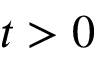Convert formula to latex. <formula><loc_0><loc_0><loc_500><loc_500>t > 0</formula> 